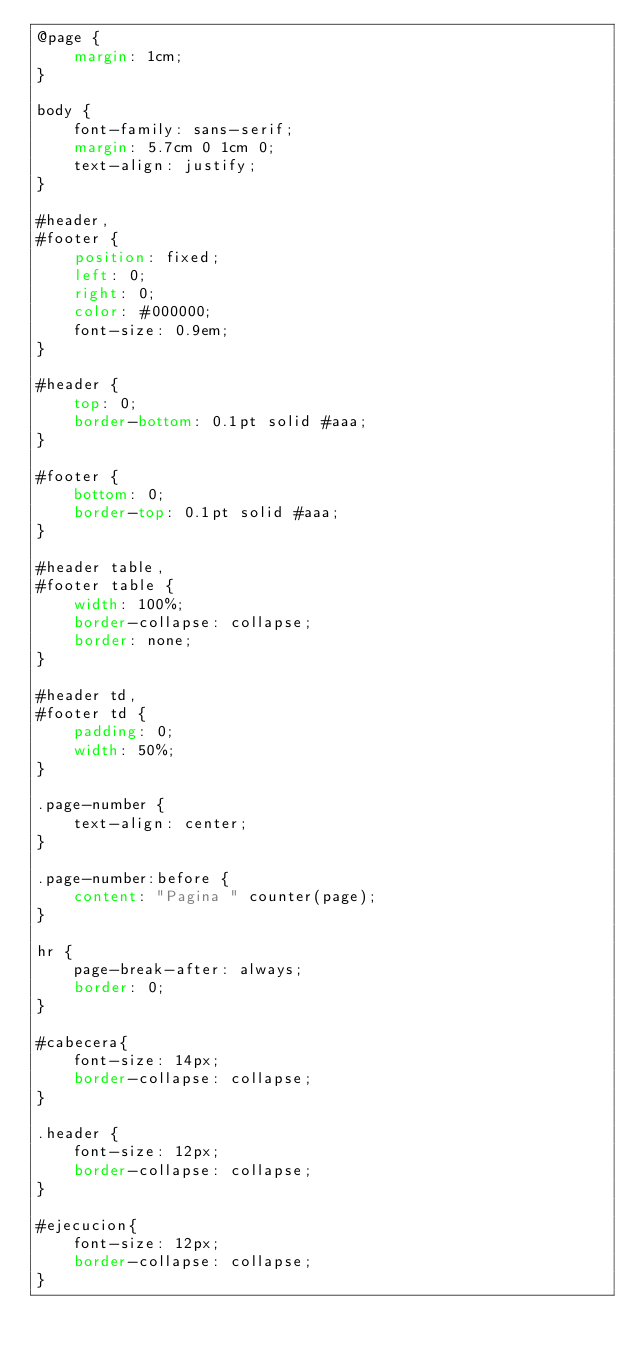Convert code to text. <code><loc_0><loc_0><loc_500><loc_500><_CSS_>@page {
    margin: 1cm;
}

body {
    font-family: sans-serif;
    margin: 5.7cm 0 1cm 0;
    text-align: justify;
}

#header,
#footer {
    position: fixed;
    left: 0;
    right: 0;
    color: #000000;
    font-size: 0.9em;
}

#header {
    top: 0;
    border-bottom: 0.1pt solid #aaa;
}

#footer {
    bottom: 0;
    border-top: 0.1pt solid #aaa;
}

#header table,
#footer table {
    width: 100%;
    border-collapse: collapse;
    border: none;
}

#header td,
#footer td {
    padding: 0;
    width: 50%;
}

.page-number {
    text-align: center;
}

.page-number:before {
    content: "Pagina " counter(page);
}

hr {
    page-break-after: always;
    border: 0;
}

#cabecera{
    font-size: 14px;
    border-collapse: collapse;
}

.header {
    font-size: 12px;
    border-collapse: collapse;
}

#ejecucion{
    font-size: 12px;
    border-collapse: collapse;
}</code> 